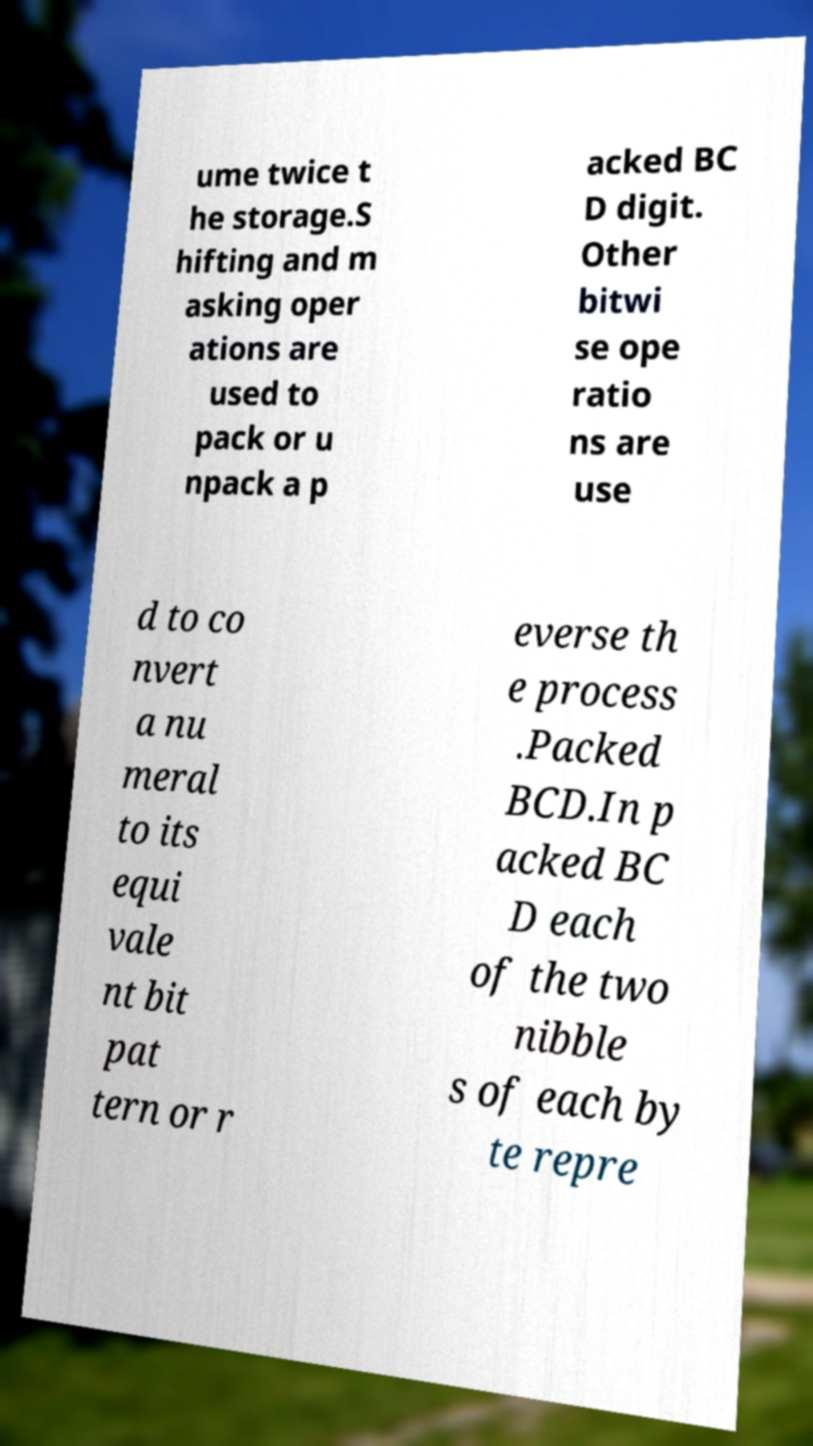Please identify and transcribe the text found in this image. ume twice t he storage.S hifting and m asking oper ations are used to pack or u npack a p acked BC D digit. Other bitwi se ope ratio ns are use d to co nvert a nu meral to its equi vale nt bit pat tern or r everse th e process .Packed BCD.In p acked BC D each of the two nibble s of each by te repre 